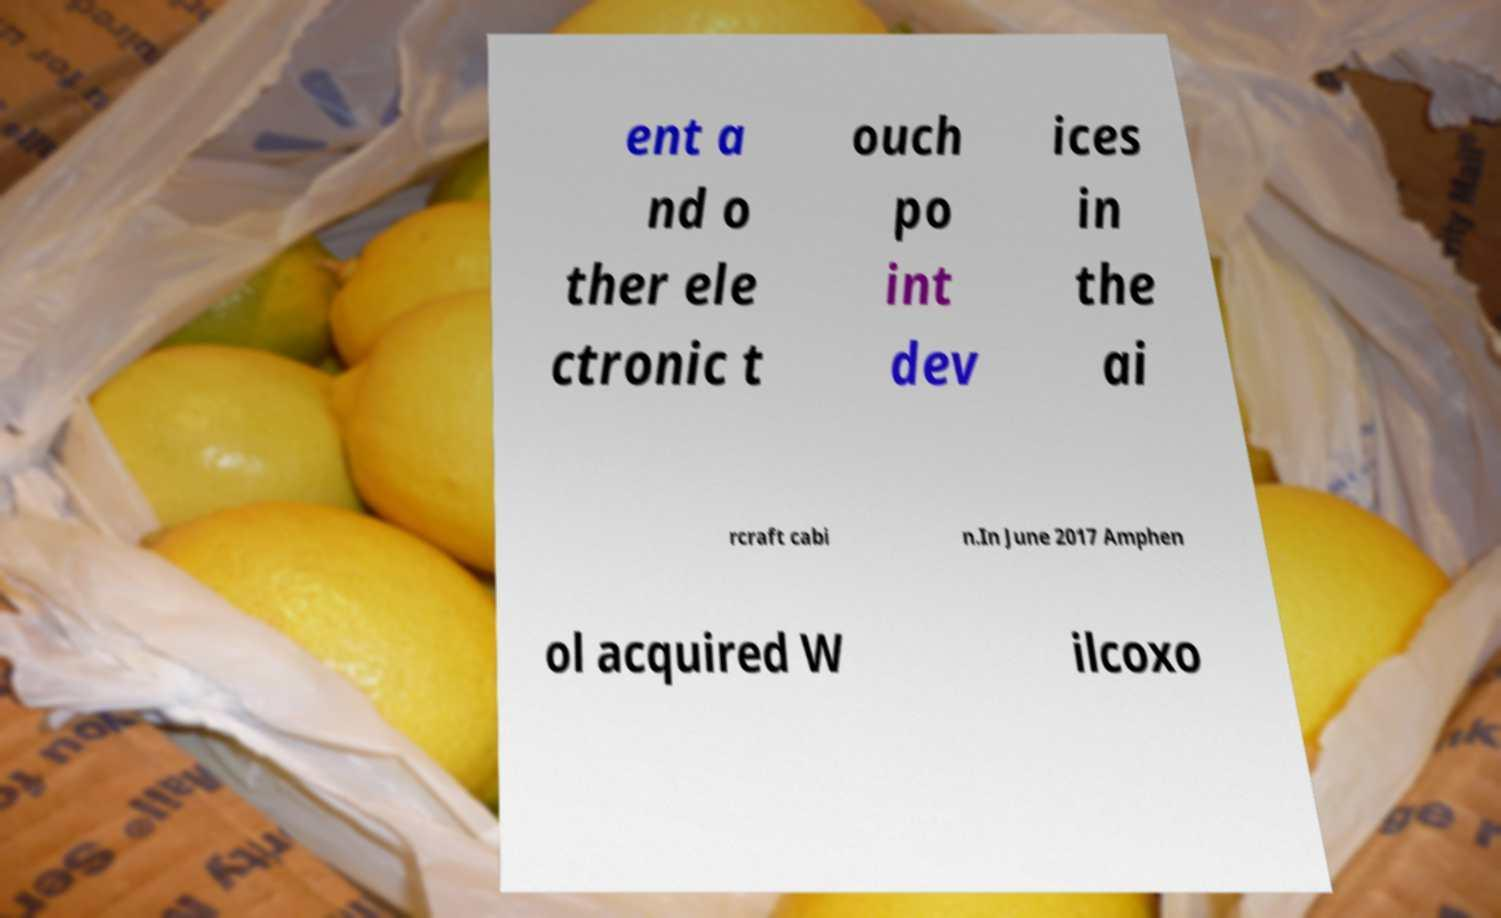Could you assist in decoding the text presented in this image and type it out clearly? ent a nd o ther ele ctronic t ouch po int dev ices in the ai rcraft cabi n.In June 2017 Amphen ol acquired W ilcoxo 